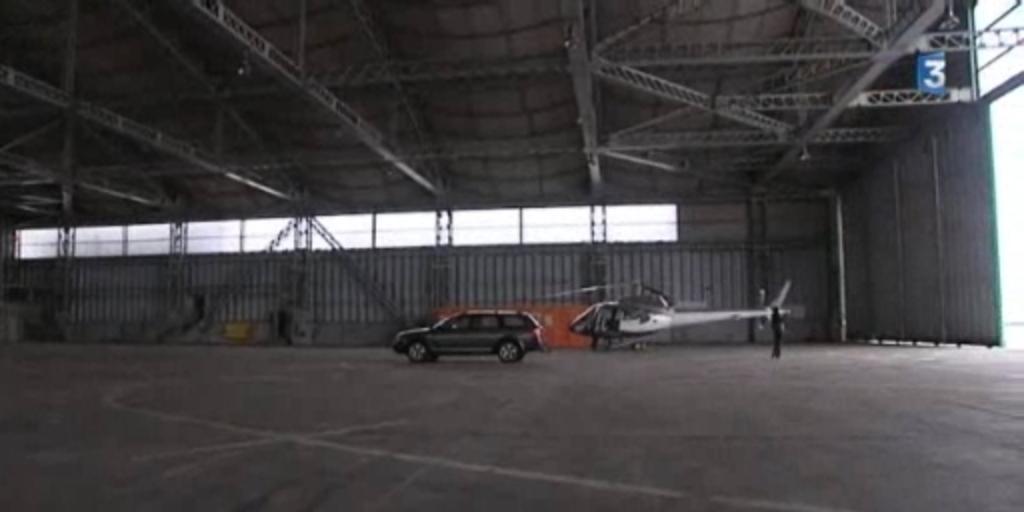What number hanger does this take place in?
Provide a short and direct response. 3. 